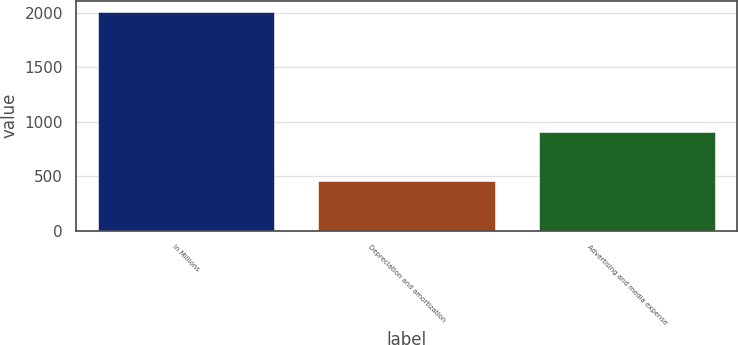Convert chart. <chart><loc_0><loc_0><loc_500><loc_500><bar_chart><fcel>In Millions<fcel>Depreciation and amortization<fcel>Advertising and media expense<nl><fcel>2010<fcel>457.1<fcel>908.5<nl></chart> 